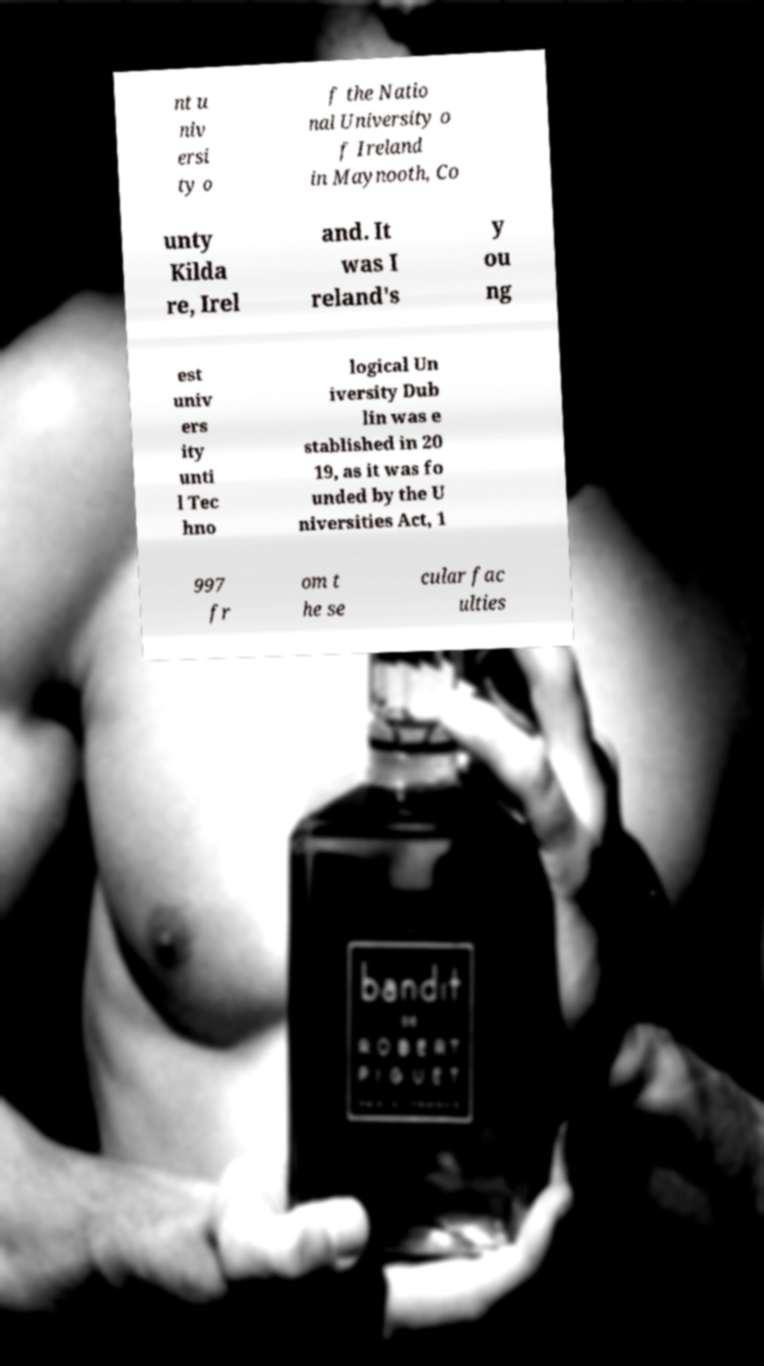Could you extract and type out the text from this image? nt u niv ersi ty o f the Natio nal University o f Ireland in Maynooth, Co unty Kilda re, Irel and. It was I reland's y ou ng est univ ers ity unti l Tec hno logical Un iversity Dub lin was e stablished in 20 19, as it was fo unded by the U niversities Act, 1 997 fr om t he se cular fac ulties 